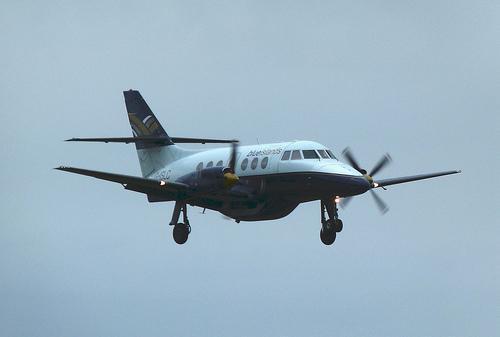How many planes are in the picture?
Give a very brief answer. 1. 